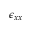<formula> <loc_0><loc_0><loc_500><loc_500>\epsilon _ { x x }</formula> 